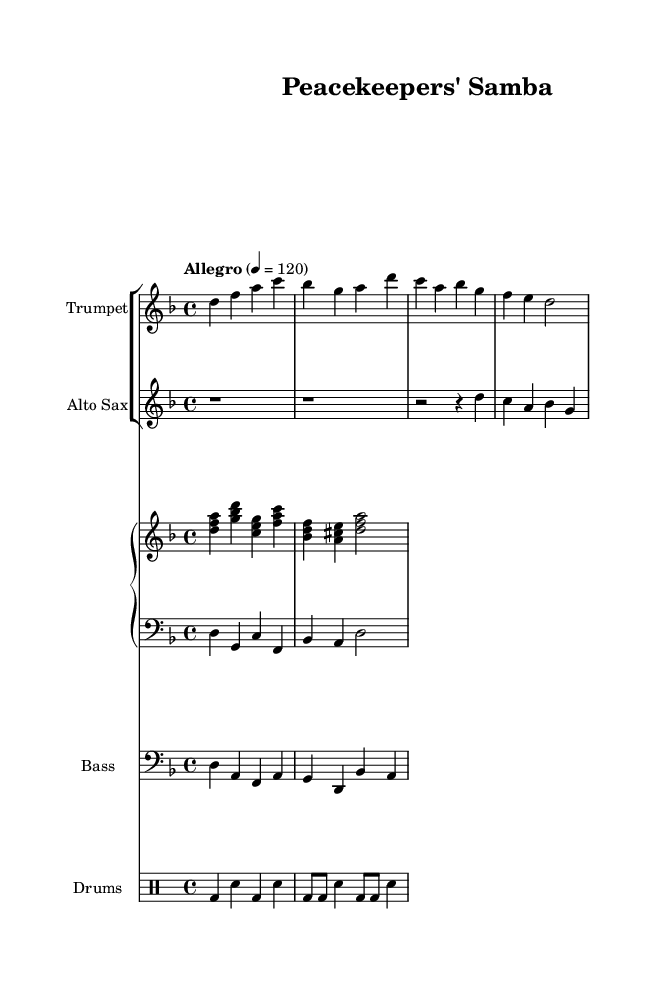What is the key signature of this music? The key signature is D minor, which contains one flat (B flat). The presence of one flat is indicated at the beginning of the staff.
Answer: D minor What is the time signature of this music? The time signature is 4/4, which means there are four beats in each measure, and the quarter note gets one beat. This is indicated at the beginning of the score.
Answer: 4/4 What is the tempo marking for the music? The tempo marking is "Allegro," which suggests a lively and upbeat tempo. This is indicated in the score, along with the metronome marking of 120 beats per minute.
Answer: Allegro How many measures are there in the trumpet music? There are four measures in the trumpet music section, which can be counted by looking at the bar lines separating the rhythmic groups in that part.
Answer: Four What instruments are featured in this ensemble? The featured instruments are trumpet, alto saxophone, piano (with both right and left hand parts), bass, and drums. Each instrument is labeled above its respective staff in the score.
Answer: Trumpet, Alto Sax, Piano, Bass, Drums What rhythmic pattern is used in the drum part? The drum part primarily uses a combination of bass drum (bd) and snare drum (sn) in a repetitive rhythmic pattern. This can be observed in the percussion staff.
Answer: Basic rhythmic pattern What type of musical style does this piece represent? The piece represents Latin jazz fusion, as indicated by the title "Peacekeepers' Samba," which suggests a blend of Latin rhythms with jazz influences.
Answer: Latin jazz fusion 